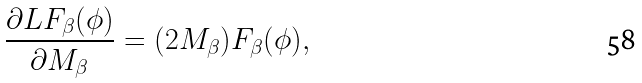<formula> <loc_0><loc_0><loc_500><loc_500>\frac { \partial L F _ { \beta } ( \phi ) } { \partial M _ { \beta } } = ( 2 M _ { \beta } ) F _ { \beta } ( \phi ) ,</formula> 